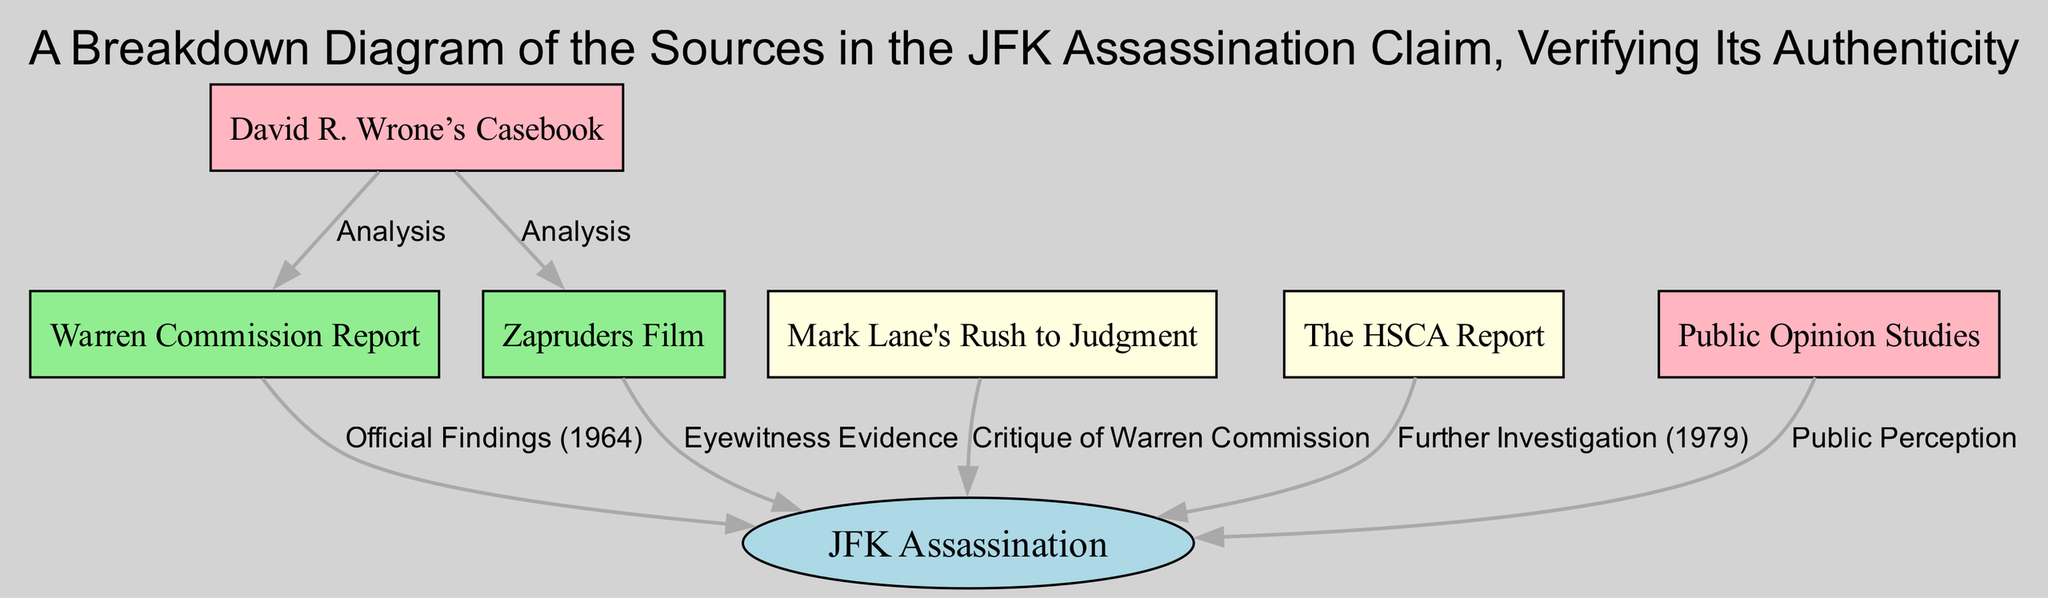What is the main historical claim represented in the diagram? The diagram's title indicates that the main historical claim is "JFK Assassination". This can be found directly in the "Claim" node, which summarizes the subject of the entire diagram.
Answer: JFK Assassination How many primary sources are associated with the claim? The diagram includes two nodes labeled as primary sources: "Warren Commission Report" and "Zapruders Film". Counting these gives a total of two primary sources associated with the claim.
Answer: 2 What type of source is "Mark Lane's Rush to Judgment"? This source is categorized under "Secondary Source 1" as indicated in the diagram, which distinguishes it from primary and tertiary sources.
Answer: Secondary Which source critiques the Warren Commission's findings? The arrow labeled "Critique of Warren Commission" leads from "Mark Lane's Rush to Judgment" to the "Claim", illustrating that this source offers a critique of the official findings.
Answer: Mark Lane's Rush to Judgment What kind of evidence does the "Zapruders Film" represent? The diagram states that the "Zapruders Film" is classified as "Eyewitness Evidence", suggesting that this source directly supports the claim with visual proof.
Answer: Eyewitness Evidence From the tertiary sources, which one analyzes "Warren Commission Report"? The "David R. Wrone's Casebook" has an edge labeled "Analysis" leading to "Warren Commission Report", indicating that it provides an analysis of that specific primary source.
Answer: David R. Wrone’s Casebook What does the "HSCA Report" provide in relation to the claim? According to the diagram, the "HSCA Report" is noted for "Further Investigation (1979)", showing that it was an investigative follow-up to the initial findings related to the claim.
Answer: Further Investigation (1979) How many tertiary sources are shown in the diagram? The diagram lists two tertiary sources: "David R. Wrone’s Casebook" and "Public Opinion Studies". This totals two tertiary sources depicted in the breakdown.
Answer: 2 What type of source is "Public Opinion Studies"? The diagram classifies "Public Opinion Studies" as a tertiary source, which illustrates its role in reflecting how the public perceives the claim rather than presenting original evidence.
Answer: Tertiary 